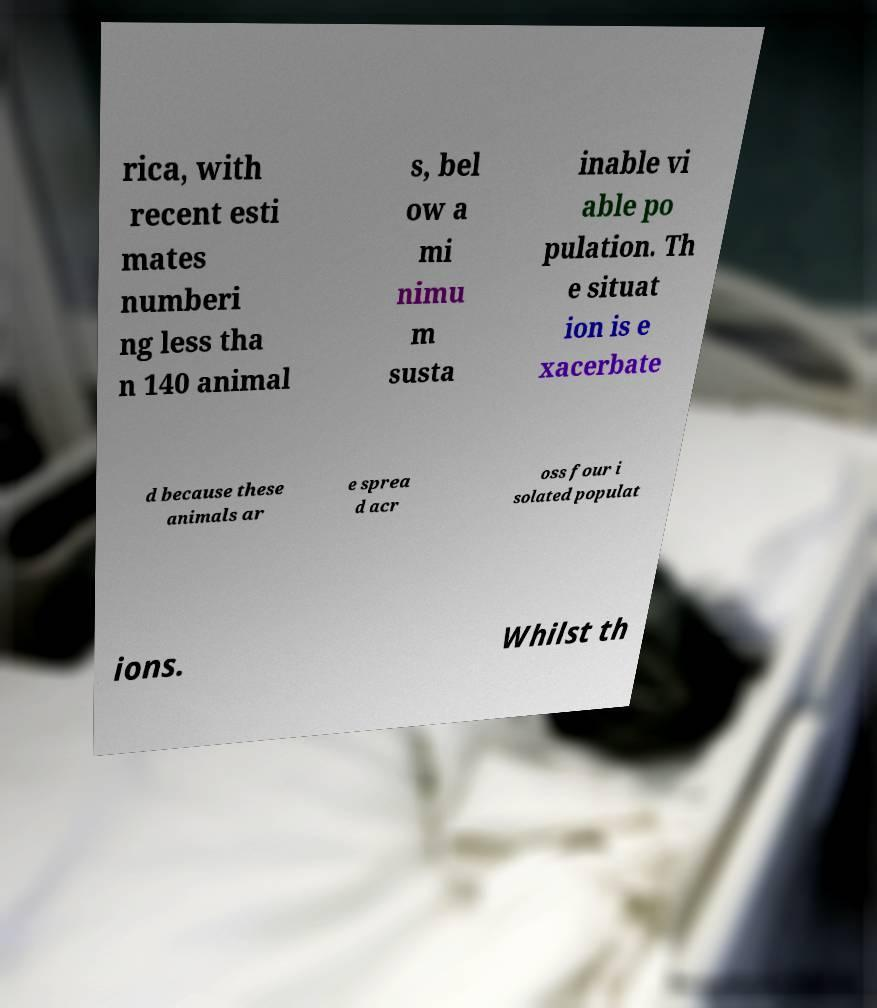Could you assist in decoding the text presented in this image and type it out clearly? rica, with recent esti mates numberi ng less tha n 140 animal s, bel ow a mi nimu m susta inable vi able po pulation. Th e situat ion is e xacerbate d because these animals ar e sprea d acr oss four i solated populat ions. Whilst th 